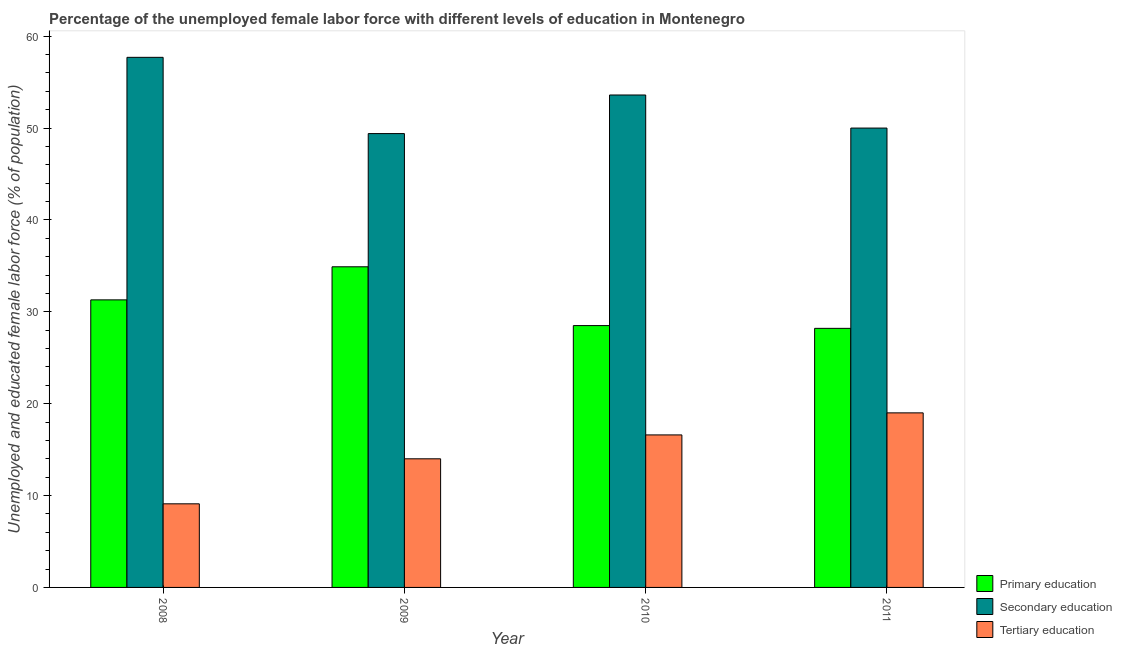How many different coloured bars are there?
Provide a short and direct response. 3. How many groups of bars are there?
Provide a short and direct response. 4. How many bars are there on the 3rd tick from the left?
Your response must be concise. 3. What is the label of the 2nd group of bars from the left?
Your response must be concise. 2009. What is the percentage of female labor force who received secondary education in 2008?
Make the answer very short. 57.7. Across all years, what is the minimum percentage of female labor force who received primary education?
Your answer should be very brief. 28.2. What is the total percentage of female labor force who received secondary education in the graph?
Give a very brief answer. 210.7. What is the difference between the percentage of female labor force who received primary education in 2008 and that in 2011?
Offer a terse response. 3.1. What is the difference between the percentage of female labor force who received tertiary education in 2010 and the percentage of female labor force who received secondary education in 2008?
Offer a very short reply. 7.5. What is the average percentage of female labor force who received primary education per year?
Offer a very short reply. 30.73. What is the ratio of the percentage of female labor force who received secondary education in 2009 to that in 2010?
Ensure brevity in your answer.  0.92. Is the difference between the percentage of female labor force who received primary education in 2009 and 2011 greater than the difference between the percentage of female labor force who received secondary education in 2009 and 2011?
Provide a succinct answer. No. What is the difference between the highest and the second highest percentage of female labor force who received tertiary education?
Your answer should be very brief. 2.4. What is the difference between the highest and the lowest percentage of female labor force who received primary education?
Offer a terse response. 6.7. In how many years, is the percentage of female labor force who received tertiary education greater than the average percentage of female labor force who received tertiary education taken over all years?
Your answer should be very brief. 2. What does the 2nd bar from the left in 2009 represents?
Your response must be concise. Secondary education. What does the 2nd bar from the right in 2008 represents?
Offer a very short reply. Secondary education. What is the difference between two consecutive major ticks on the Y-axis?
Offer a very short reply. 10. Does the graph contain any zero values?
Provide a short and direct response. No. Where does the legend appear in the graph?
Provide a short and direct response. Bottom right. How many legend labels are there?
Offer a very short reply. 3. What is the title of the graph?
Your response must be concise. Percentage of the unemployed female labor force with different levels of education in Montenegro. Does "Oil" appear as one of the legend labels in the graph?
Make the answer very short. No. What is the label or title of the X-axis?
Provide a succinct answer. Year. What is the label or title of the Y-axis?
Ensure brevity in your answer.  Unemployed and educated female labor force (% of population). What is the Unemployed and educated female labor force (% of population) of Primary education in 2008?
Ensure brevity in your answer.  31.3. What is the Unemployed and educated female labor force (% of population) of Secondary education in 2008?
Offer a terse response. 57.7. What is the Unemployed and educated female labor force (% of population) of Tertiary education in 2008?
Make the answer very short. 9.1. What is the Unemployed and educated female labor force (% of population) of Primary education in 2009?
Provide a short and direct response. 34.9. What is the Unemployed and educated female labor force (% of population) in Secondary education in 2009?
Offer a terse response. 49.4. What is the Unemployed and educated female labor force (% of population) of Tertiary education in 2009?
Give a very brief answer. 14. What is the Unemployed and educated female labor force (% of population) of Primary education in 2010?
Give a very brief answer. 28.5. What is the Unemployed and educated female labor force (% of population) of Secondary education in 2010?
Provide a short and direct response. 53.6. What is the Unemployed and educated female labor force (% of population) of Tertiary education in 2010?
Your response must be concise. 16.6. What is the Unemployed and educated female labor force (% of population) in Primary education in 2011?
Give a very brief answer. 28.2. What is the Unemployed and educated female labor force (% of population) in Tertiary education in 2011?
Provide a short and direct response. 19. Across all years, what is the maximum Unemployed and educated female labor force (% of population) in Primary education?
Provide a succinct answer. 34.9. Across all years, what is the maximum Unemployed and educated female labor force (% of population) in Secondary education?
Provide a short and direct response. 57.7. Across all years, what is the maximum Unemployed and educated female labor force (% of population) in Tertiary education?
Your answer should be very brief. 19. Across all years, what is the minimum Unemployed and educated female labor force (% of population) of Primary education?
Provide a succinct answer. 28.2. Across all years, what is the minimum Unemployed and educated female labor force (% of population) in Secondary education?
Your answer should be very brief. 49.4. Across all years, what is the minimum Unemployed and educated female labor force (% of population) in Tertiary education?
Give a very brief answer. 9.1. What is the total Unemployed and educated female labor force (% of population) of Primary education in the graph?
Make the answer very short. 122.9. What is the total Unemployed and educated female labor force (% of population) in Secondary education in the graph?
Provide a short and direct response. 210.7. What is the total Unemployed and educated female labor force (% of population) in Tertiary education in the graph?
Your answer should be very brief. 58.7. What is the difference between the Unemployed and educated female labor force (% of population) in Primary education in 2008 and that in 2009?
Give a very brief answer. -3.6. What is the difference between the Unemployed and educated female labor force (% of population) of Tertiary education in 2008 and that in 2009?
Offer a very short reply. -4.9. What is the difference between the Unemployed and educated female labor force (% of population) in Tertiary education in 2008 and that in 2011?
Your response must be concise. -9.9. What is the difference between the Unemployed and educated female labor force (% of population) in Primary education in 2009 and that in 2010?
Provide a short and direct response. 6.4. What is the difference between the Unemployed and educated female labor force (% of population) of Tertiary education in 2009 and that in 2010?
Provide a short and direct response. -2.6. What is the difference between the Unemployed and educated female labor force (% of population) in Primary education in 2008 and the Unemployed and educated female labor force (% of population) in Secondary education in 2009?
Your answer should be compact. -18.1. What is the difference between the Unemployed and educated female labor force (% of population) in Primary education in 2008 and the Unemployed and educated female labor force (% of population) in Tertiary education in 2009?
Keep it short and to the point. 17.3. What is the difference between the Unemployed and educated female labor force (% of population) in Secondary education in 2008 and the Unemployed and educated female labor force (% of population) in Tertiary education in 2009?
Your response must be concise. 43.7. What is the difference between the Unemployed and educated female labor force (% of population) of Primary education in 2008 and the Unemployed and educated female labor force (% of population) of Secondary education in 2010?
Keep it short and to the point. -22.3. What is the difference between the Unemployed and educated female labor force (% of population) in Primary education in 2008 and the Unemployed and educated female labor force (% of population) in Tertiary education in 2010?
Provide a short and direct response. 14.7. What is the difference between the Unemployed and educated female labor force (% of population) of Secondary education in 2008 and the Unemployed and educated female labor force (% of population) of Tertiary education in 2010?
Provide a succinct answer. 41.1. What is the difference between the Unemployed and educated female labor force (% of population) in Primary education in 2008 and the Unemployed and educated female labor force (% of population) in Secondary education in 2011?
Offer a terse response. -18.7. What is the difference between the Unemployed and educated female labor force (% of population) of Secondary education in 2008 and the Unemployed and educated female labor force (% of population) of Tertiary education in 2011?
Your answer should be very brief. 38.7. What is the difference between the Unemployed and educated female labor force (% of population) in Primary education in 2009 and the Unemployed and educated female labor force (% of population) in Secondary education in 2010?
Make the answer very short. -18.7. What is the difference between the Unemployed and educated female labor force (% of population) of Secondary education in 2009 and the Unemployed and educated female labor force (% of population) of Tertiary education in 2010?
Give a very brief answer. 32.8. What is the difference between the Unemployed and educated female labor force (% of population) of Primary education in 2009 and the Unemployed and educated female labor force (% of population) of Secondary education in 2011?
Keep it short and to the point. -15.1. What is the difference between the Unemployed and educated female labor force (% of population) in Primary education in 2009 and the Unemployed and educated female labor force (% of population) in Tertiary education in 2011?
Make the answer very short. 15.9. What is the difference between the Unemployed and educated female labor force (% of population) in Secondary education in 2009 and the Unemployed and educated female labor force (% of population) in Tertiary education in 2011?
Make the answer very short. 30.4. What is the difference between the Unemployed and educated female labor force (% of population) of Primary education in 2010 and the Unemployed and educated female labor force (% of population) of Secondary education in 2011?
Your answer should be compact. -21.5. What is the difference between the Unemployed and educated female labor force (% of population) in Secondary education in 2010 and the Unemployed and educated female labor force (% of population) in Tertiary education in 2011?
Offer a terse response. 34.6. What is the average Unemployed and educated female labor force (% of population) of Primary education per year?
Ensure brevity in your answer.  30.73. What is the average Unemployed and educated female labor force (% of population) in Secondary education per year?
Offer a very short reply. 52.67. What is the average Unemployed and educated female labor force (% of population) of Tertiary education per year?
Ensure brevity in your answer.  14.68. In the year 2008, what is the difference between the Unemployed and educated female labor force (% of population) in Primary education and Unemployed and educated female labor force (% of population) in Secondary education?
Keep it short and to the point. -26.4. In the year 2008, what is the difference between the Unemployed and educated female labor force (% of population) of Secondary education and Unemployed and educated female labor force (% of population) of Tertiary education?
Your answer should be very brief. 48.6. In the year 2009, what is the difference between the Unemployed and educated female labor force (% of population) of Primary education and Unemployed and educated female labor force (% of population) of Tertiary education?
Offer a terse response. 20.9. In the year 2009, what is the difference between the Unemployed and educated female labor force (% of population) of Secondary education and Unemployed and educated female labor force (% of population) of Tertiary education?
Ensure brevity in your answer.  35.4. In the year 2010, what is the difference between the Unemployed and educated female labor force (% of population) in Primary education and Unemployed and educated female labor force (% of population) in Secondary education?
Provide a short and direct response. -25.1. In the year 2010, what is the difference between the Unemployed and educated female labor force (% of population) of Secondary education and Unemployed and educated female labor force (% of population) of Tertiary education?
Your answer should be compact. 37. In the year 2011, what is the difference between the Unemployed and educated female labor force (% of population) of Primary education and Unemployed and educated female labor force (% of population) of Secondary education?
Your answer should be compact. -21.8. In the year 2011, what is the difference between the Unemployed and educated female labor force (% of population) in Primary education and Unemployed and educated female labor force (% of population) in Tertiary education?
Give a very brief answer. 9.2. In the year 2011, what is the difference between the Unemployed and educated female labor force (% of population) of Secondary education and Unemployed and educated female labor force (% of population) of Tertiary education?
Your answer should be compact. 31. What is the ratio of the Unemployed and educated female labor force (% of population) in Primary education in 2008 to that in 2009?
Your response must be concise. 0.9. What is the ratio of the Unemployed and educated female labor force (% of population) of Secondary education in 2008 to that in 2009?
Provide a succinct answer. 1.17. What is the ratio of the Unemployed and educated female labor force (% of population) of Tertiary education in 2008 to that in 2009?
Your answer should be very brief. 0.65. What is the ratio of the Unemployed and educated female labor force (% of population) of Primary education in 2008 to that in 2010?
Make the answer very short. 1.1. What is the ratio of the Unemployed and educated female labor force (% of population) of Secondary education in 2008 to that in 2010?
Give a very brief answer. 1.08. What is the ratio of the Unemployed and educated female labor force (% of population) of Tertiary education in 2008 to that in 2010?
Give a very brief answer. 0.55. What is the ratio of the Unemployed and educated female labor force (% of population) of Primary education in 2008 to that in 2011?
Give a very brief answer. 1.11. What is the ratio of the Unemployed and educated female labor force (% of population) of Secondary education in 2008 to that in 2011?
Ensure brevity in your answer.  1.15. What is the ratio of the Unemployed and educated female labor force (% of population) in Tertiary education in 2008 to that in 2011?
Offer a terse response. 0.48. What is the ratio of the Unemployed and educated female labor force (% of population) of Primary education in 2009 to that in 2010?
Give a very brief answer. 1.22. What is the ratio of the Unemployed and educated female labor force (% of population) in Secondary education in 2009 to that in 2010?
Provide a short and direct response. 0.92. What is the ratio of the Unemployed and educated female labor force (% of population) in Tertiary education in 2009 to that in 2010?
Provide a succinct answer. 0.84. What is the ratio of the Unemployed and educated female labor force (% of population) in Primary education in 2009 to that in 2011?
Make the answer very short. 1.24. What is the ratio of the Unemployed and educated female labor force (% of population) in Secondary education in 2009 to that in 2011?
Give a very brief answer. 0.99. What is the ratio of the Unemployed and educated female labor force (% of population) of Tertiary education in 2009 to that in 2011?
Your answer should be very brief. 0.74. What is the ratio of the Unemployed and educated female labor force (% of population) in Primary education in 2010 to that in 2011?
Ensure brevity in your answer.  1.01. What is the ratio of the Unemployed and educated female labor force (% of population) in Secondary education in 2010 to that in 2011?
Your answer should be compact. 1.07. What is the ratio of the Unemployed and educated female labor force (% of population) of Tertiary education in 2010 to that in 2011?
Make the answer very short. 0.87. What is the difference between the highest and the second highest Unemployed and educated female labor force (% of population) in Primary education?
Keep it short and to the point. 3.6. What is the difference between the highest and the second highest Unemployed and educated female labor force (% of population) of Secondary education?
Provide a succinct answer. 4.1. 